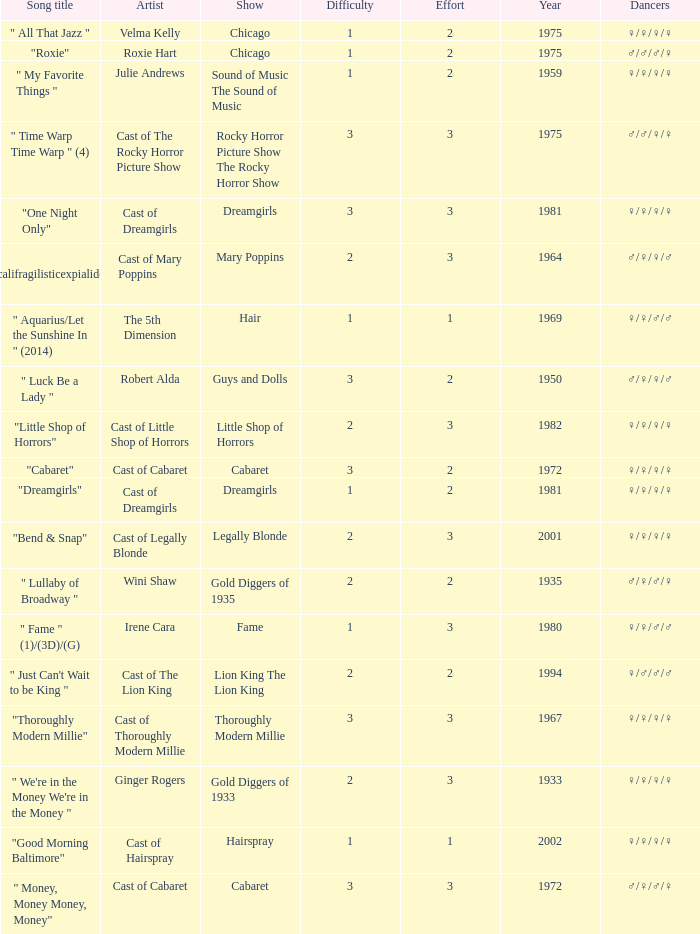How many shows were in 1994? 1.0. 